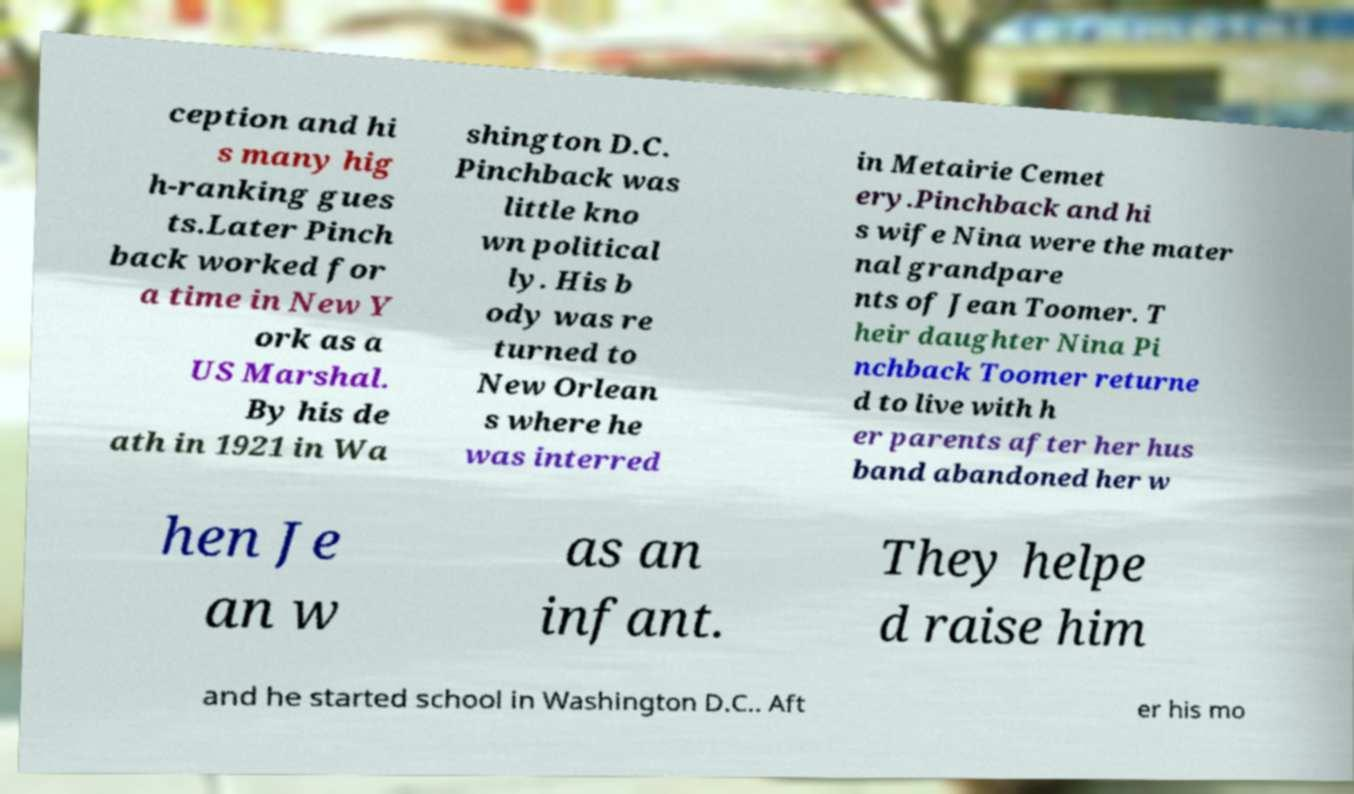What messages or text are displayed in this image? I need them in a readable, typed format. ception and hi s many hig h-ranking gues ts.Later Pinch back worked for a time in New Y ork as a US Marshal. By his de ath in 1921 in Wa shington D.C. Pinchback was little kno wn political ly. His b ody was re turned to New Orlean s where he was interred in Metairie Cemet ery.Pinchback and hi s wife Nina were the mater nal grandpare nts of Jean Toomer. T heir daughter Nina Pi nchback Toomer returne d to live with h er parents after her hus band abandoned her w hen Je an w as an infant. They helpe d raise him and he started school in Washington D.C.. Aft er his mo 